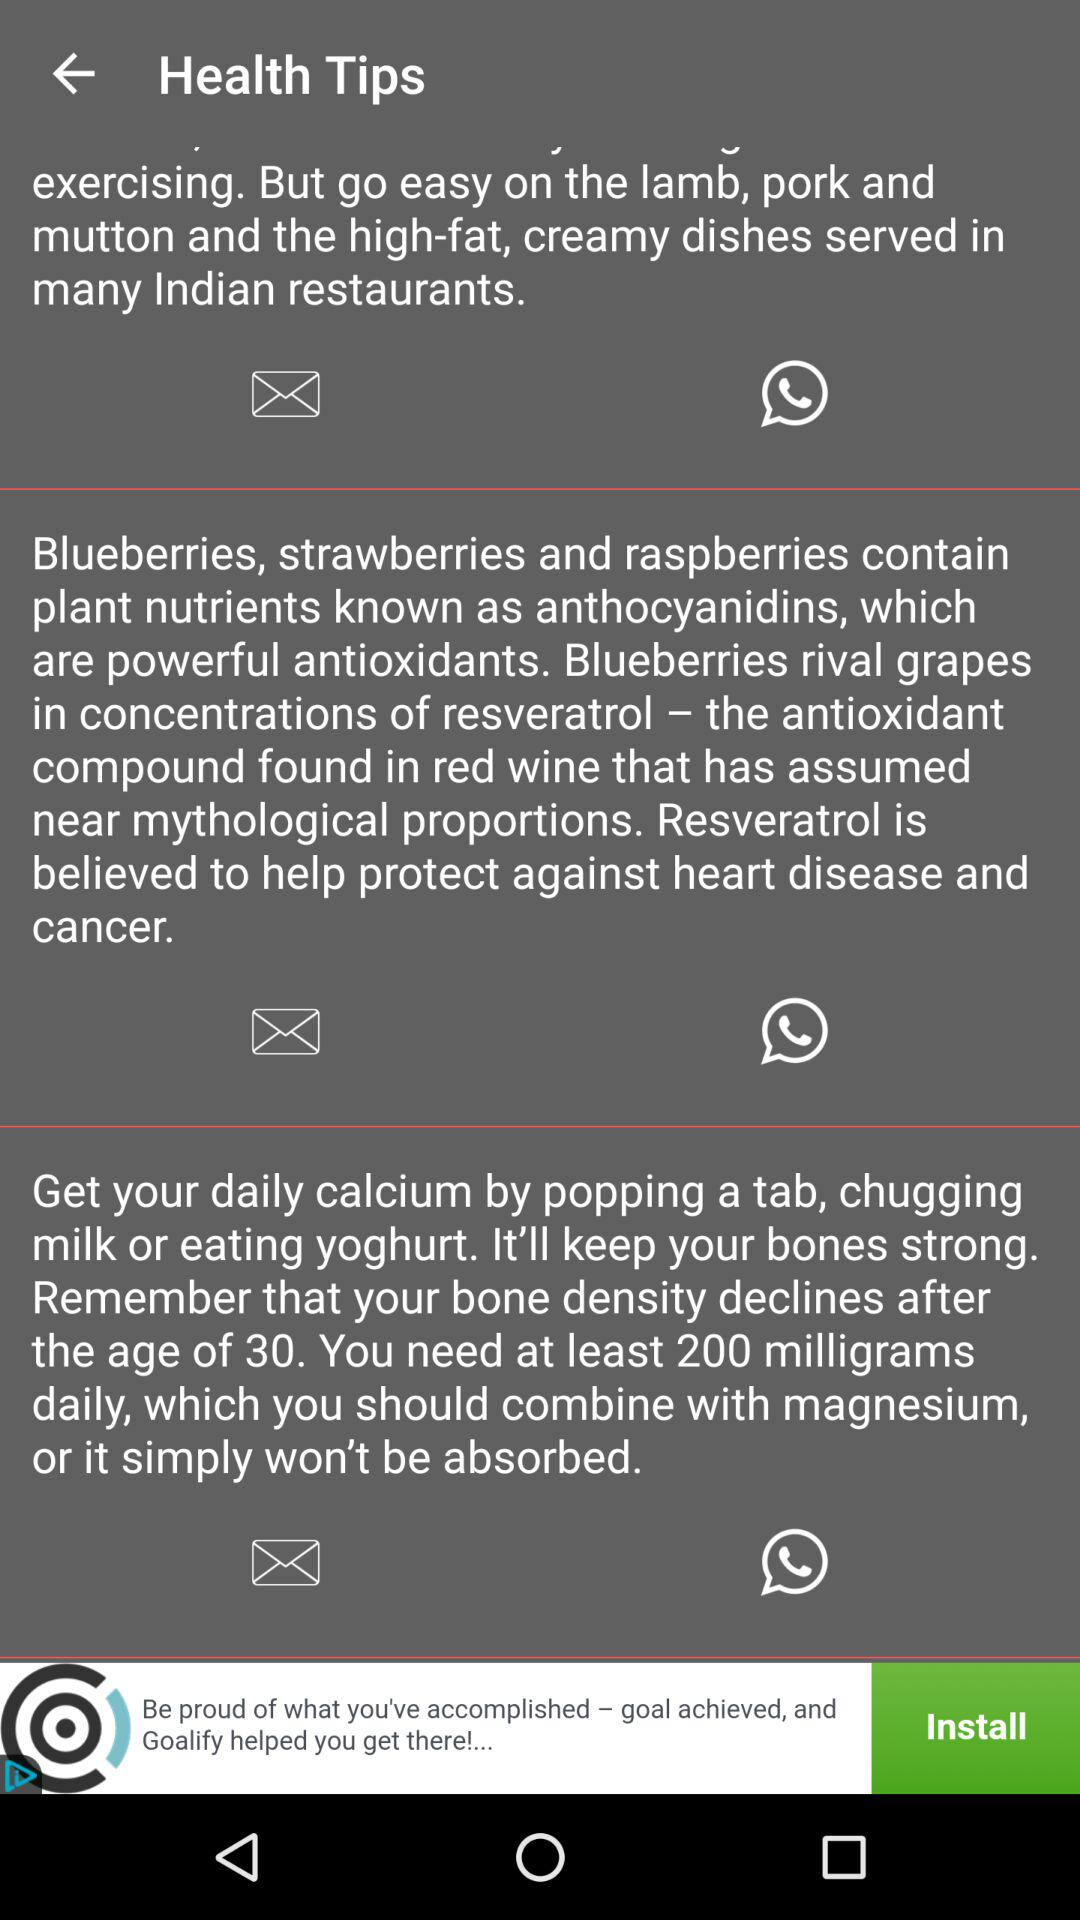Which fruits contain plant nutrients known as anthocyanidins? The fruits that contain plant nutrients known as anthocyanidins are blueberries, strawberries and raspberries. 